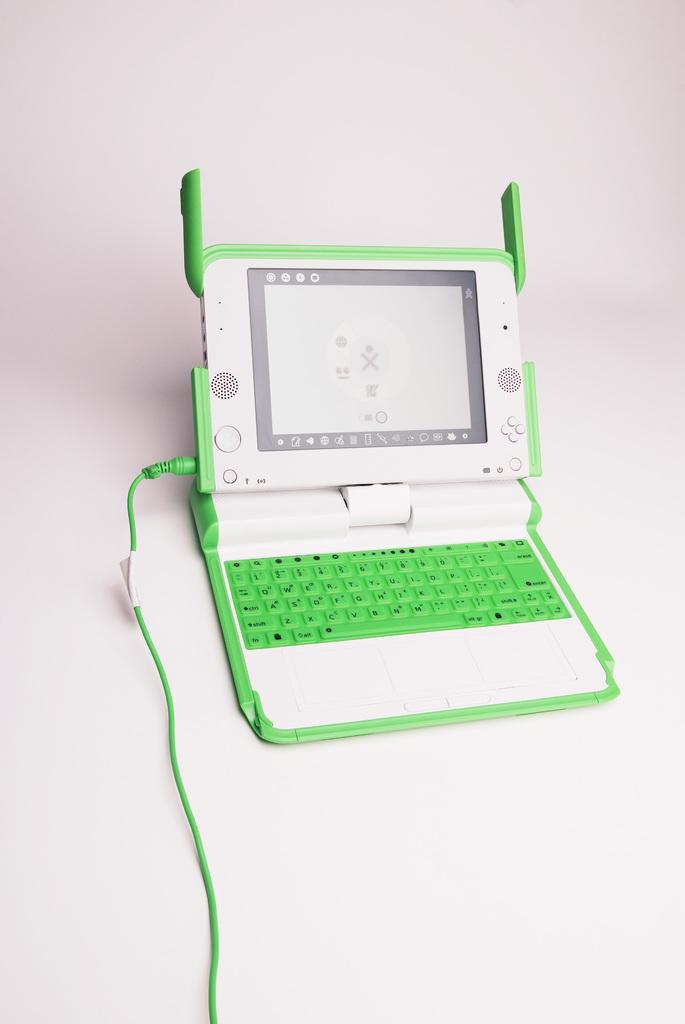What type of device is visible in the image? There is a device in the image. What features does the device have? The device has a keyboard, a screen, buttons, and a cable. Where is the device located in the image? The device is placed on a surface in the image. What type of yam is growing on the device in the image? There is no yam present in the image, and the device is not a plant or a growing medium for yams. 